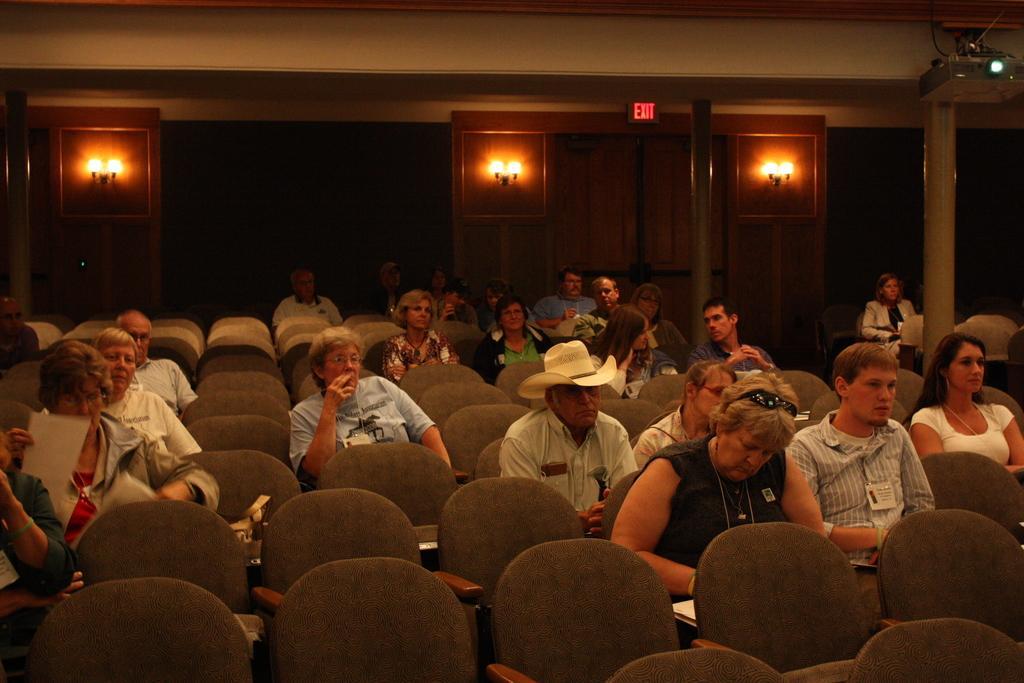How would you summarize this image in a sentence or two? This picture is taken in a room. There are group of people sitting on chairs. Towards the right, there is a woman in black clothes and she is writing something. Towards the left, there is another person and he is holding a paper. In the center, there is a man wearing a cream shirt and cream hat. In the background, there are lights. At the top right, there is a projector. 